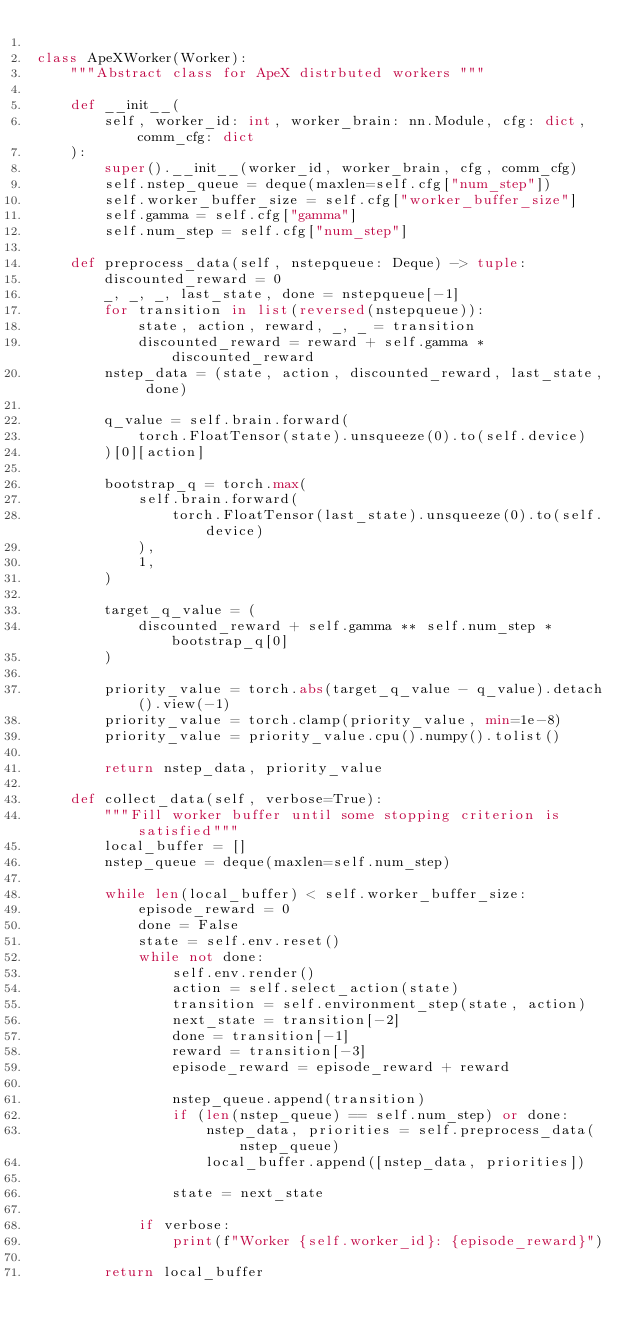Convert code to text. <code><loc_0><loc_0><loc_500><loc_500><_Python_>
class ApeXWorker(Worker):
    """Abstract class for ApeX distrbuted workers """

    def __init__(
        self, worker_id: int, worker_brain: nn.Module, cfg: dict, comm_cfg: dict
    ):
        super().__init__(worker_id, worker_brain, cfg, comm_cfg)
        self.nstep_queue = deque(maxlen=self.cfg["num_step"])
        self.worker_buffer_size = self.cfg["worker_buffer_size"]
        self.gamma = self.cfg["gamma"]
        self.num_step = self.cfg["num_step"]

    def preprocess_data(self, nstepqueue: Deque) -> tuple:
        discounted_reward = 0
        _, _, _, last_state, done = nstepqueue[-1]
        for transition in list(reversed(nstepqueue)):
            state, action, reward, _, _ = transition
            discounted_reward = reward + self.gamma * discounted_reward
        nstep_data = (state, action, discounted_reward, last_state, done)

        q_value = self.brain.forward(
            torch.FloatTensor(state).unsqueeze(0).to(self.device)
        )[0][action]

        bootstrap_q = torch.max(
            self.brain.forward(
                torch.FloatTensor(last_state).unsqueeze(0).to(self.device)
            ),
            1,
        )

        target_q_value = (
            discounted_reward + self.gamma ** self.num_step * bootstrap_q[0]
        )

        priority_value = torch.abs(target_q_value - q_value).detach().view(-1)
        priority_value = torch.clamp(priority_value, min=1e-8)
        priority_value = priority_value.cpu().numpy().tolist()

        return nstep_data, priority_value

    def collect_data(self, verbose=True):
        """Fill worker buffer until some stopping criterion is satisfied"""
        local_buffer = []
        nstep_queue = deque(maxlen=self.num_step)

        while len(local_buffer) < self.worker_buffer_size:
            episode_reward = 0
            done = False
            state = self.env.reset()
            while not done:
                self.env.render()
                action = self.select_action(state)
                transition = self.environment_step(state, action)
                next_state = transition[-2]
                done = transition[-1]
                reward = transition[-3]
                episode_reward = episode_reward + reward

                nstep_queue.append(transition)
                if (len(nstep_queue) == self.num_step) or done:
                    nstep_data, priorities = self.preprocess_data(nstep_queue)
                    local_buffer.append([nstep_data, priorities])

                state = next_state

            if verbose:
                print(f"Worker {self.worker_id}: {episode_reward}")

        return local_buffer
</code> 